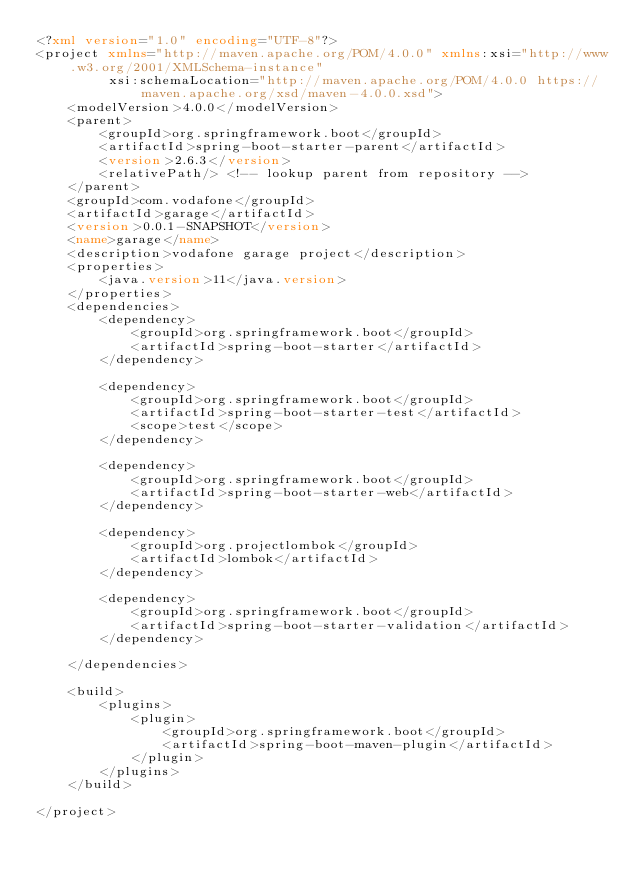Convert code to text. <code><loc_0><loc_0><loc_500><loc_500><_XML_><?xml version="1.0" encoding="UTF-8"?>
<project xmlns="http://maven.apache.org/POM/4.0.0" xmlns:xsi="http://www.w3.org/2001/XMLSchema-instance"
         xsi:schemaLocation="http://maven.apache.org/POM/4.0.0 https://maven.apache.org/xsd/maven-4.0.0.xsd">
    <modelVersion>4.0.0</modelVersion>
    <parent>
        <groupId>org.springframework.boot</groupId>
        <artifactId>spring-boot-starter-parent</artifactId>
        <version>2.6.3</version>
        <relativePath/> <!-- lookup parent from repository -->
    </parent>
    <groupId>com.vodafone</groupId>
    <artifactId>garage</artifactId>
    <version>0.0.1-SNAPSHOT</version>
    <name>garage</name>
    <description>vodafone garage project</description>
    <properties>
        <java.version>11</java.version>
    </properties>
    <dependencies>
        <dependency>
            <groupId>org.springframework.boot</groupId>
            <artifactId>spring-boot-starter</artifactId>
        </dependency>

        <dependency>
            <groupId>org.springframework.boot</groupId>
            <artifactId>spring-boot-starter-test</artifactId>
            <scope>test</scope>
        </dependency>

        <dependency>
            <groupId>org.springframework.boot</groupId>
            <artifactId>spring-boot-starter-web</artifactId>
        </dependency>

        <dependency>
            <groupId>org.projectlombok</groupId>
            <artifactId>lombok</artifactId>
        </dependency>

        <dependency>
            <groupId>org.springframework.boot</groupId>
            <artifactId>spring-boot-starter-validation</artifactId>
        </dependency>

    </dependencies>

    <build>
        <plugins>
            <plugin>
                <groupId>org.springframework.boot</groupId>
                <artifactId>spring-boot-maven-plugin</artifactId>
            </plugin>
        </plugins>
    </build>

</project>
</code> 